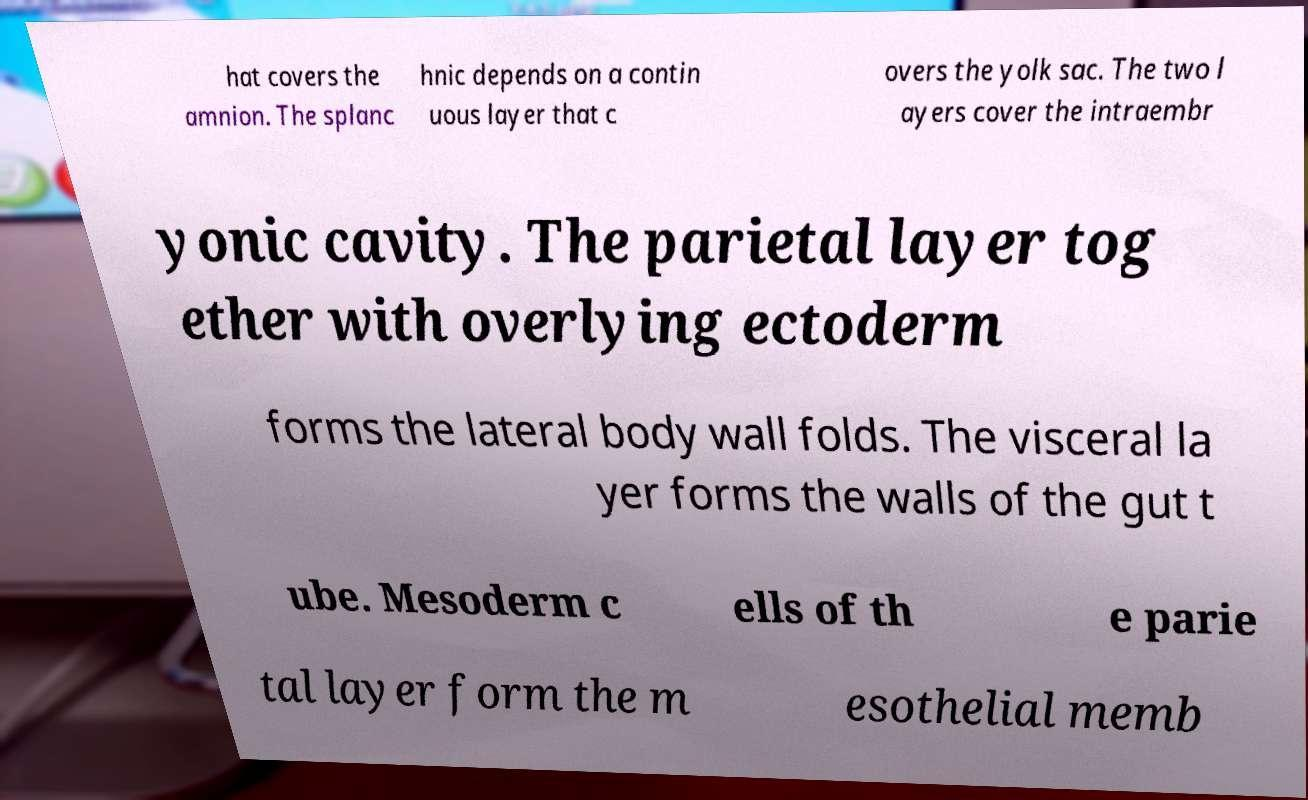Please read and relay the text visible in this image. What does it say? hat covers the amnion. The splanc hnic depends on a contin uous layer that c overs the yolk sac. The two l ayers cover the intraembr yonic cavity. The parietal layer tog ether with overlying ectoderm forms the lateral body wall folds. The visceral la yer forms the walls of the gut t ube. Mesoderm c ells of th e parie tal layer form the m esothelial memb 